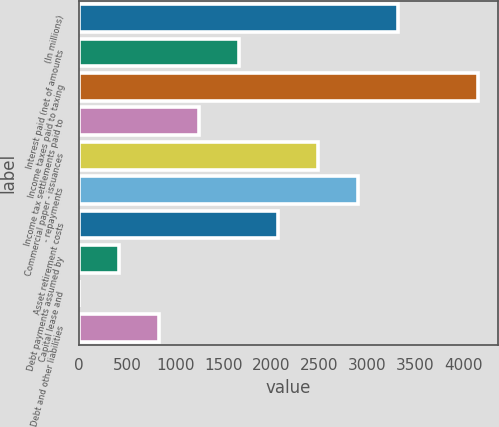Convert chart. <chart><loc_0><loc_0><loc_500><loc_500><bar_chart><fcel>(In millions)<fcel>Interest paid (net of amounts<fcel>Income taxes paid to taxing<fcel>Income tax settlements paid to<fcel>Commercial paper - issuances<fcel>- repayments<fcel>Asset retirement costs<fcel>Debt payments assumed by<fcel>Capital lease and<fcel>Debt and other liabilities<nl><fcel>3319.4<fcel>1660.2<fcel>4149<fcel>1245.4<fcel>2489.8<fcel>2904.6<fcel>2075<fcel>415.8<fcel>1<fcel>830.6<nl></chart> 